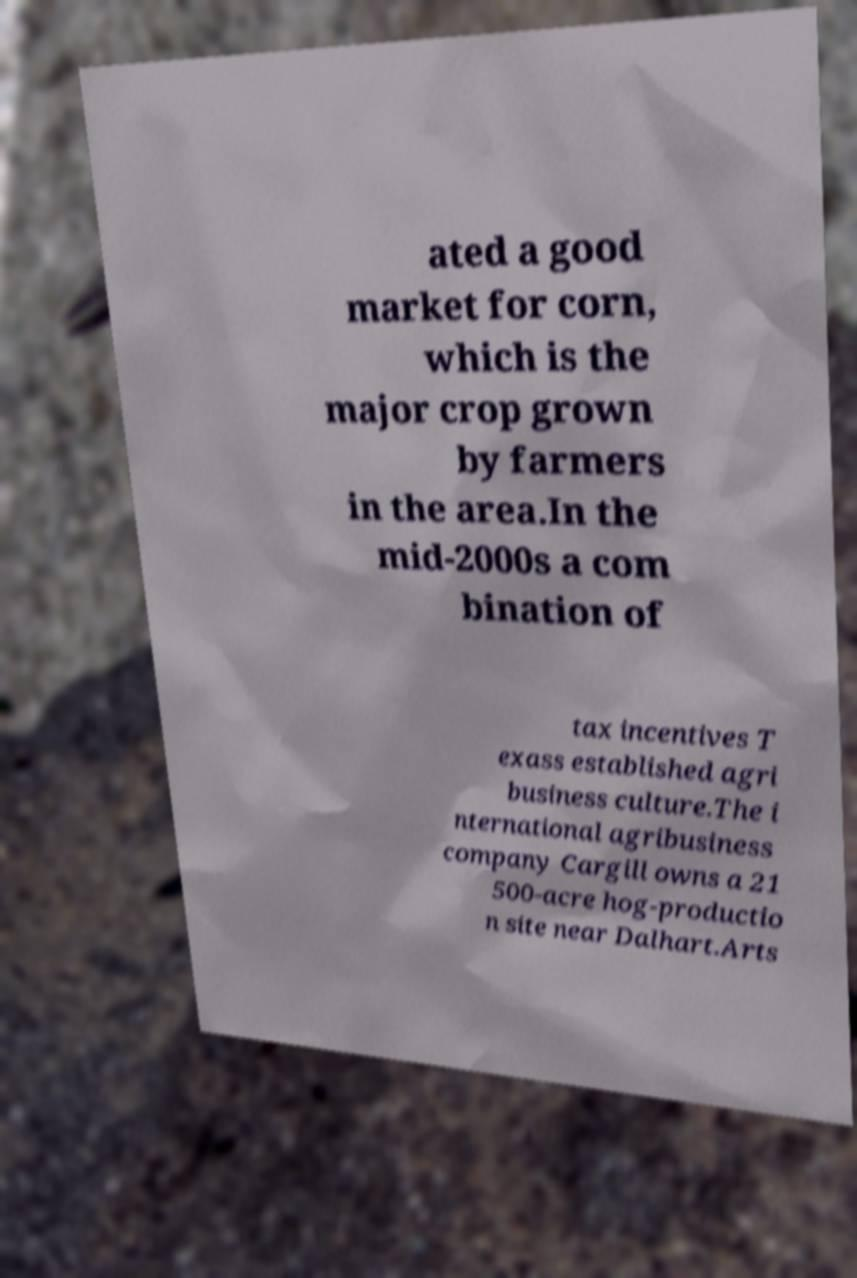Please identify and transcribe the text found in this image. ated a good market for corn, which is the major crop grown by farmers in the area.In the mid-2000s a com bination of tax incentives T exass established agri business culture.The i nternational agribusiness company Cargill owns a 21 500-acre hog-productio n site near Dalhart.Arts 